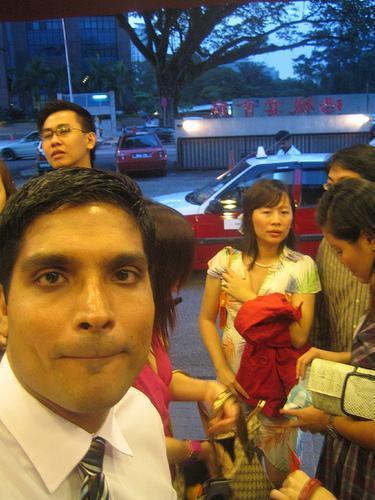How many cars are there?
Give a very brief answer. 1. How many people can be seen?
Give a very brief answer. 6. How many sheep is there?
Give a very brief answer. 0. 